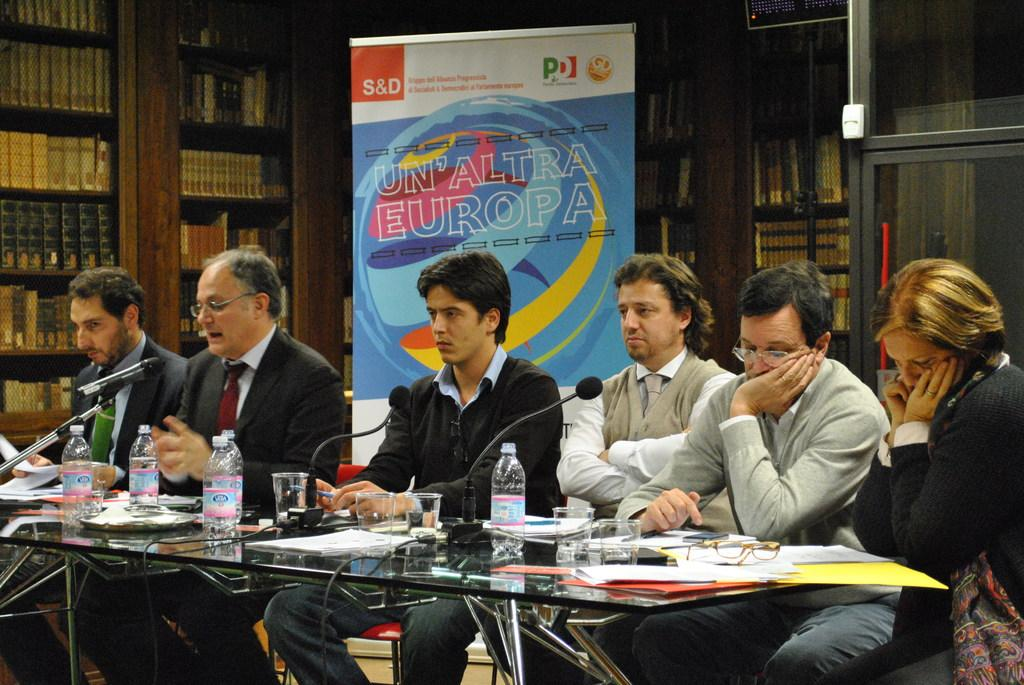<image>
Offer a succinct explanation of the picture presented. the word Europa that is on a sign next to people 